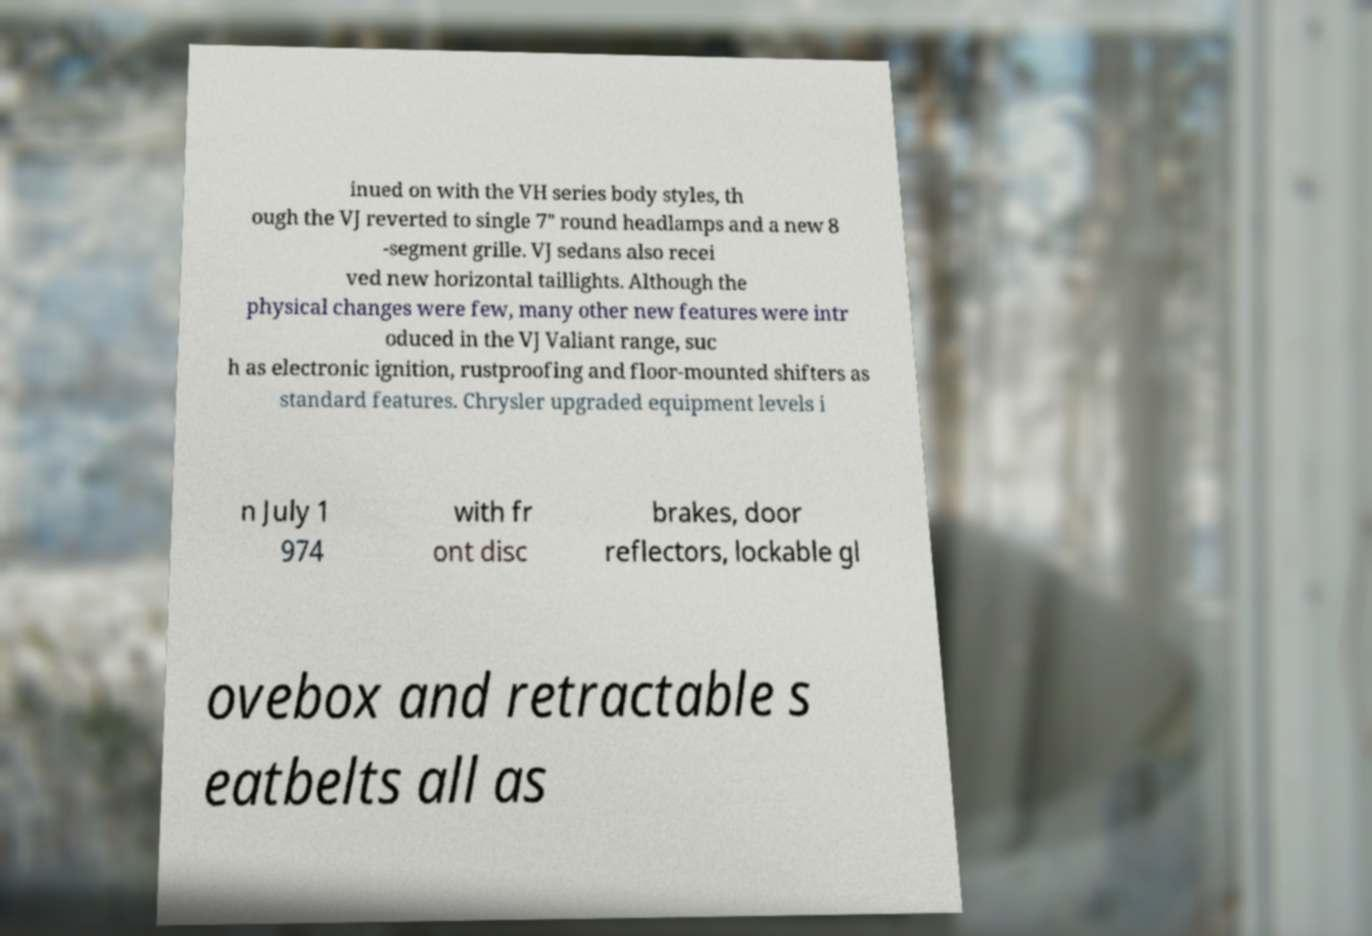Please identify and transcribe the text found in this image. inued on with the VH series body styles, th ough the VJ reverted to single 7" round headlamps and a new 8 -segment grille. VJ sedans also recei ved new horizontal taillights. Although the physical changes were few, many other new features were intr oduced in the VJ Valiant range, suc h as electronic ignition, rustproofing and floor-mounted shifters as standard features. Chrysler upgraded equipment levels i n July 1 974 with fr ont disc brakes, door reflectors, lockable gl ovebox and retractable s eatbelts all as 